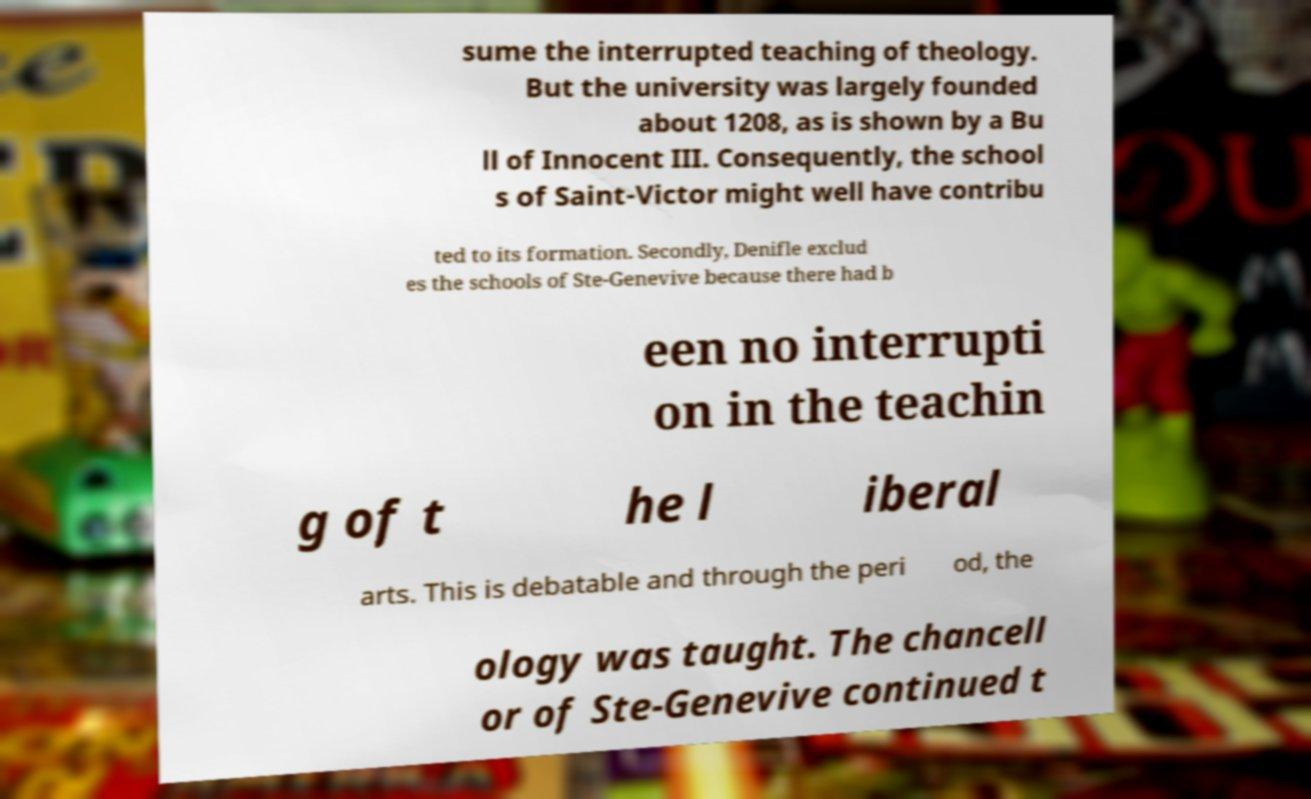I need the written content from this picture converted into text. Can you do that? sume the interrupted teaching of theology. But the university was largely founded about 1208, as is shown by a Bu ll of Innocent III. Consequently, the school s of Saint-Victor might well have contribu ted to its formation. Secondly, Denifle exclud es the schools of Ste-Genevive because there had b een no interrupti on in the teachin g of t he l iberal arts. This is debatable and through the peri od, the ology was taught. The chancell or of Ste-Genevive continued t 